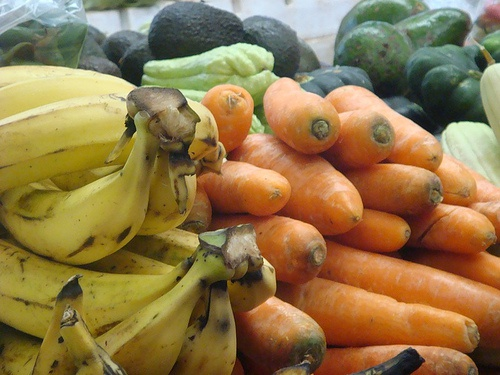Describe the objects in this image and their specific colors. I can see carrot in lightblue, brown, tan, and maroon tones, banana in lightblue and olive tones, banana in lightblue, olive, and maroon tones, banana in lightblue, khaki, and olive tones, and banana in lightblue and olive tones in this image. 